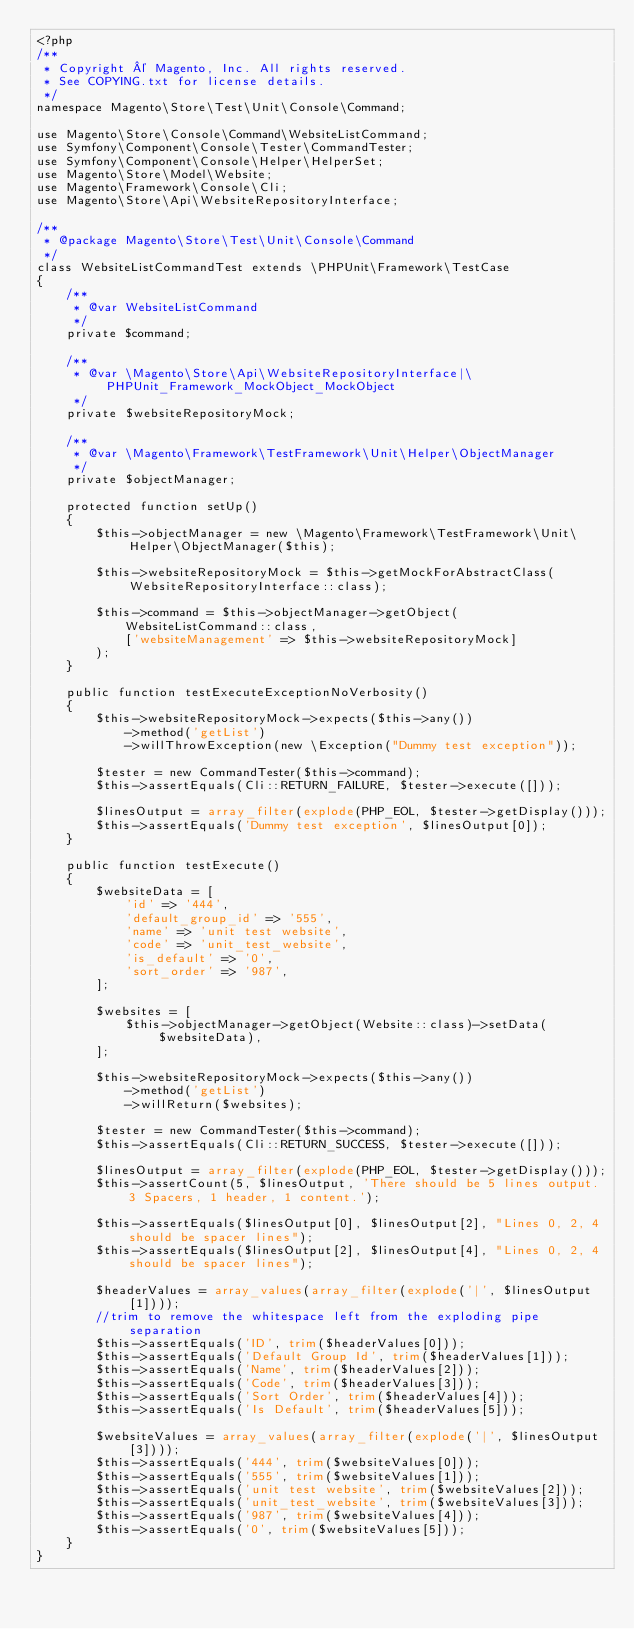<code> <loc_0><loc_0><loc_500><loc_500><_PHP_><?php
/**
 * Copyright © Magento, Inc. All rights reserved.
 * See COPYING.txt for license details.
 */
namespace Magento\Store\Test\Unit\Console\Command;

use Magento\Store\Console\Command\WebsiteListCommand;
use Symfony\Component\Console\Tester\CommandTester;
use Symfony\Component\Console\Helper\HelperSet;
use Magento\Store\Model\Website;
use Magento\Framework\Console\Cli;
use Magento\Store\Api\WebsiteRepositoryInterface;

/**
 * @package Magento\Store\Test\Unit\Console\Command
 */
class WebsiteListCommandTest extends \PHPUnit\Framework\TestCase
{
    /**
     * @var WebsiteListCommand
     */
    private $command;

    /**
     * @var \Magento\Store\Api\WebsiteRepositoryInterface|\PHPUnit_Framework_MockObject_MockObject
     */
    private $websiteRepositoryMock;

    /**
     * @var \Magento\Framework\TestFramework\Unit\Helper\ObjectManager
     */
    private $objectManager;

    protected function setUp()
    {
        $this->objectManager = new \Magento\Framework\TestFramework\Unit\Helper\ObjectManager($this);

        $this->websiteRepositoryMock = $this->getMockForAbstractClass(WebsiteRepositoryInterface::class);

        $this->command = $this->objectManager->getObject(
            WebsiteListCommand::class,
            ['websiteManagement' => $this->websiteRepositoryMock]
        );
    }

    public function testExecuteExceptionNoVerbosity()
    {
        $this->websiteRepositoryMock->expects($this->any())
            ->method('getList')
            ->willThrowException(new \Exception("Dummy test exception"));

        $tester = new CommandTester($this->command);
        $this->assertEquals(Cli::RETURN_FAILURE, $tester->execute([]));

        $linesOutput = array_filter(explode(PHP_EOL, $tester->getDisplay()));
        $this->assertEquals('Dummy test exception', $linesOutput[0]);
    }

    public function testExecute()
    {
        $websiteData = [
            'id' => '444',
            'default_group_id' => '555',
            'name' => 'unit test website',
            'code' => 'unit_test_website',
            'is_default' => '0',
            'sort_order' => '987',
        ];

        $websites = [
            $this->objectManager->getObject(Website::class)->setData($websiteData),
        ];

        $this->websiteRepositoryMock->expects($this->any())
            ->method('getList')
            ->willReturn($websites);

        $tester = new CommandTester($this->command);
        $this->assertEquals(Cli::RETURN_SUCCESS, $tester->execute([]));

        $linesOutput = array_filter(explode(PHP_EOL, $tester->getDisplay()));
        $this->assertCount(5, $linesOutput, 'There should be 5 lines output. 3 Spacers, 1 header, 1 content.');

        $this->assertEquals($linesOutput[0], $linesOutput[2], "Lines 0, 2, 4 should be spacer lines");
        $this->assertEquals($linesOutput[2], $linesOutput[4], "Lines 0, 2, 4 should be spacer lines");

        $headerValues = array_values(array_filter(explode('|', $linesOutput[1])));
        //trim to remove the whitespace left from the exploding pipe separation
        $this->assertEquals('ID', trim($headerValues[0]));
        $this->assertEquals('Default Group Id', trim($headerValues[1]));
        $this->assertEquals('Name', trim($headerValues[2]));
        $this->assertEquals('Code', trim($headerValues[3]));
        $this->assertEquals('Sort Order', trim($headerValues[4]));
        $this->assertEquals('Is Default', trim($headerValues[5]));

        $websiteValues = array_values(array_filter(explode('|', $linesOutput[3])));
        $this->assertEquals('444', trim($websiteValues[0]));
        $this->assertEquals('555', trim($websiteValues[1]));
        $this->assertEquals('unit test website', trim($websiteValues[2]));
        $this->assertEquals('unit_test_website', trim($websiteValues[3]));
        $this->assertEquals('987', trim($websiteValues[4]));
        $this->assertEquals('0', trim($websiteValues[5]));
    }
}
</code> 